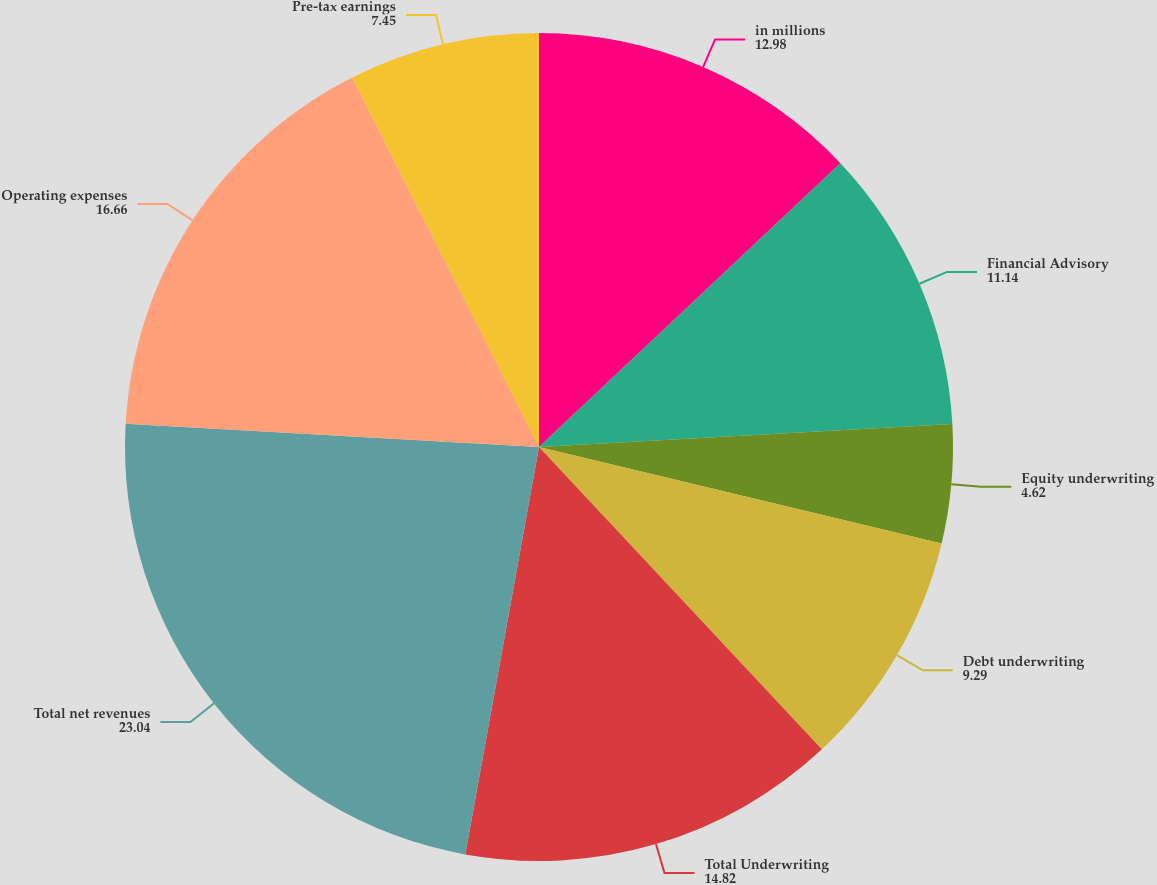<chart> <loc_0><loc_0><loc_500><loc_500><pie_chart><fcel>in millions<fcel>Financial Advisory<fcel>Equity underwriting<fcel>Debt underwriting<fcel>Total Underwriting<fcel>Total net revenues<fcel>Operating expenses<fcel>Pre-tax earnings<nl><fcel>12.98%<fcel>11.14%<fcel>4.62%<fcel>9.29%<fcel>14.82%<fcel>23.04%<fcel>16.66%<fcel>7.45%<nl></chart> 